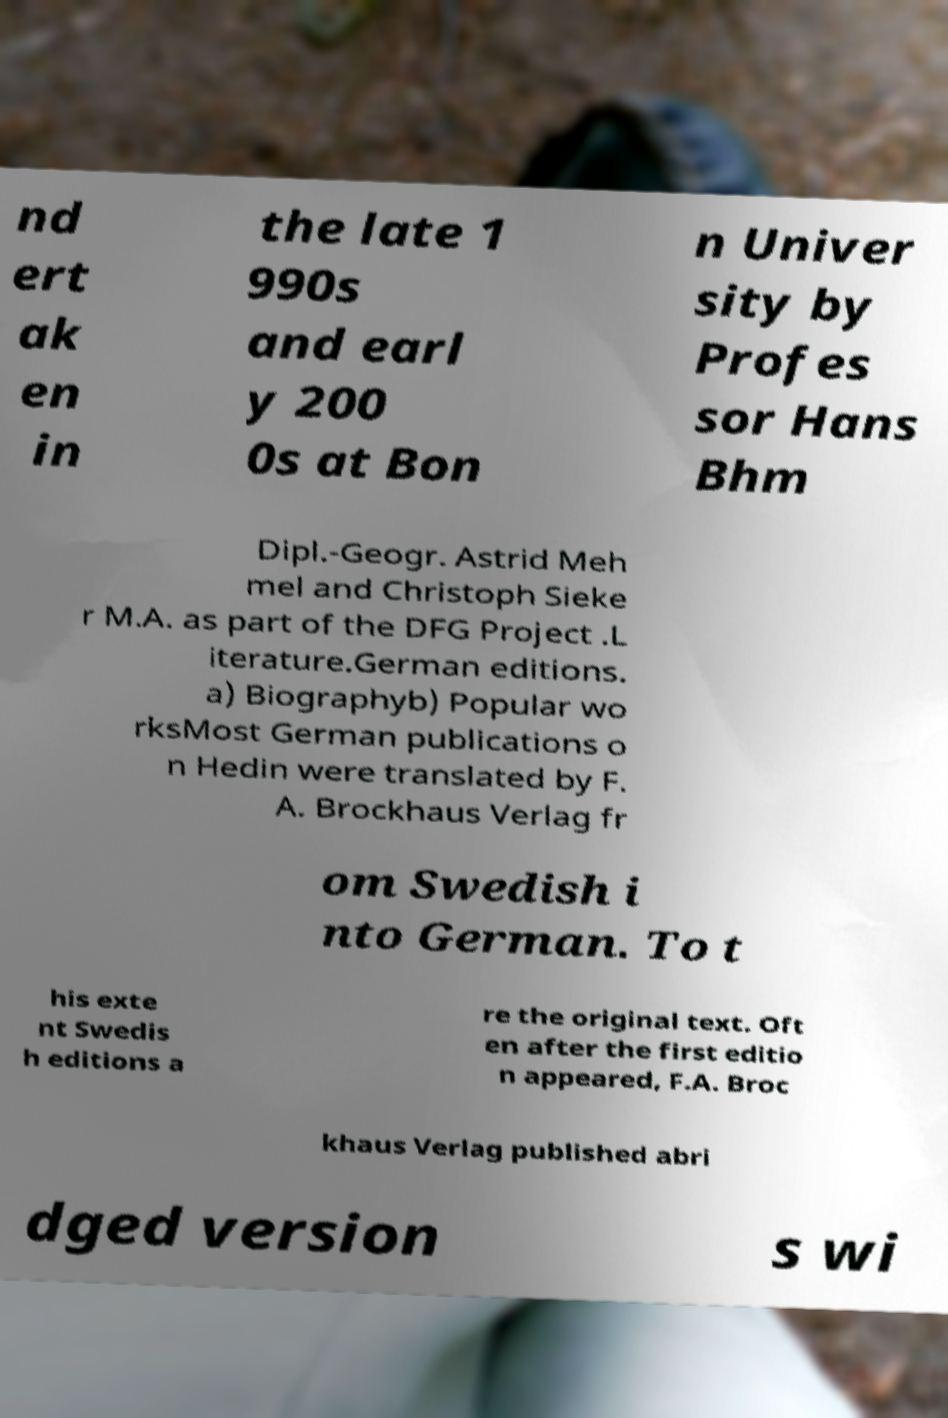Could you assist in decoding the text presented in this image and type it out clearly? nd ert ak en in the late 1 990s and earl y 200 0s at Bon n Univer sity by Profes sor Hans Bhm Dipl.-Geogr. Astrid Meh mel and Christoph Sieke r M.A. as part of the DFG Project .L iterature.German editions. a) Biographyb) Popular wo rksMost German publications o n Hedin were translated by F. A. Brockhaus Verlag fr om Swedish i nto German. To t his exte nt Swedis h editions a re the original text. Oft en after the first editio n appeared, F.A. Broc khaus Verlag published abri dged version s wi 